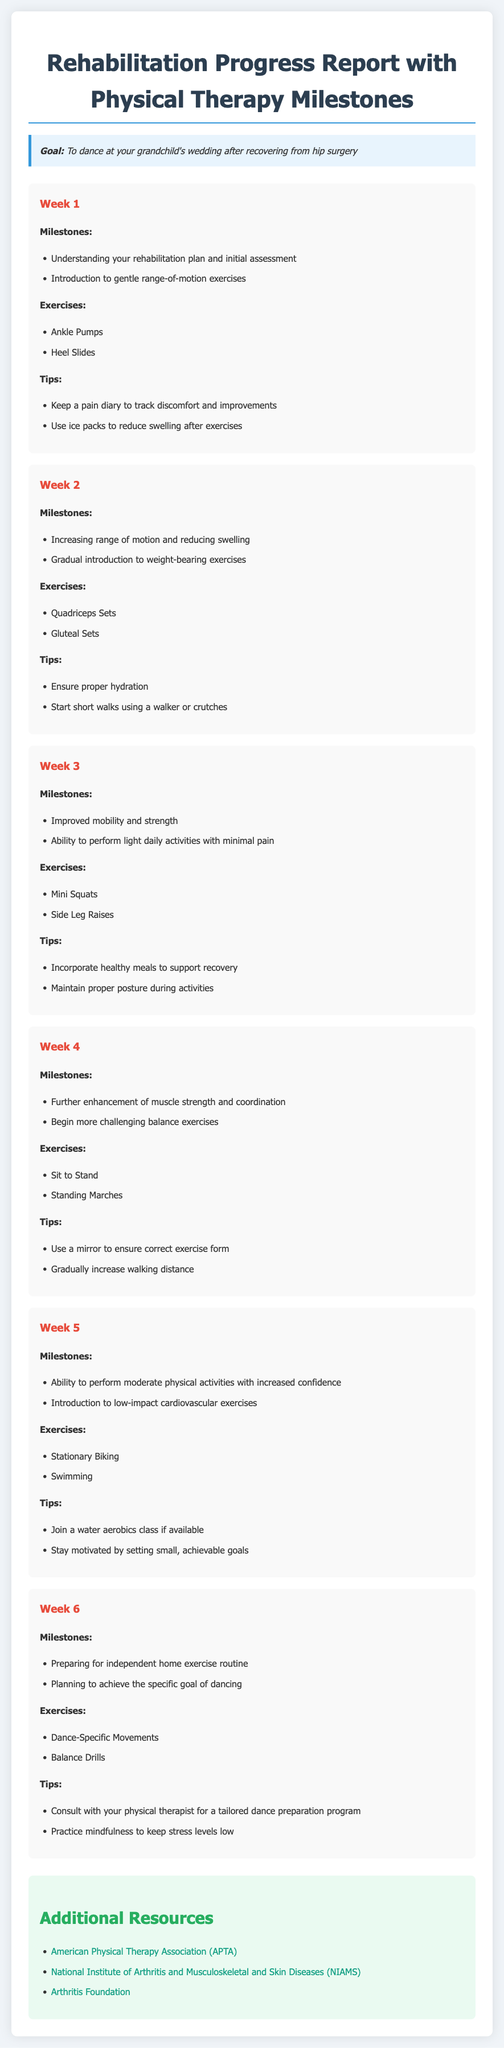What is the goal of the rehabilitation program? The goal is to dance at your grandchild's wedding after recovering from hip surgery.
Answer: To dance at your grandchild's wedding What exercise is introduced in Week 1? Week 1 includes gentle range-of-motion exercises such as Ankle Pumps and Heel Slides.
Answer: Ankle Pumps How many weeks are covered in the rehabilitation report? The report details progress over a total of 6 weeks.
Answer: 6 weeks What milestone is achieved by Week 3? By Week 3, improved mobility and strength are milestones achieved.
Answer: Improved mobility and strength What type of exercises are introduced in Week 5? In Week 5, low-impact cardiovascular exercises like Stationary Biking and Swimming are introduced.
Answer: Stationary Biking What should be done to track discomfort during rehabilitation? Keeping a pain diary is recommended to track discomfort and improvements.
Answer: Keep a pain diary Which week involves preparing for a home exercise routine? Week 6 is focused on preparing for an independent home exercise routine.
Answer: Week 6 What tip is given for Week 4 regarding exercise form? It is suggested to use a mirror to ensure correct exercise form during Week 4.
Answer: Use a mirror to ensure correct exercise form 